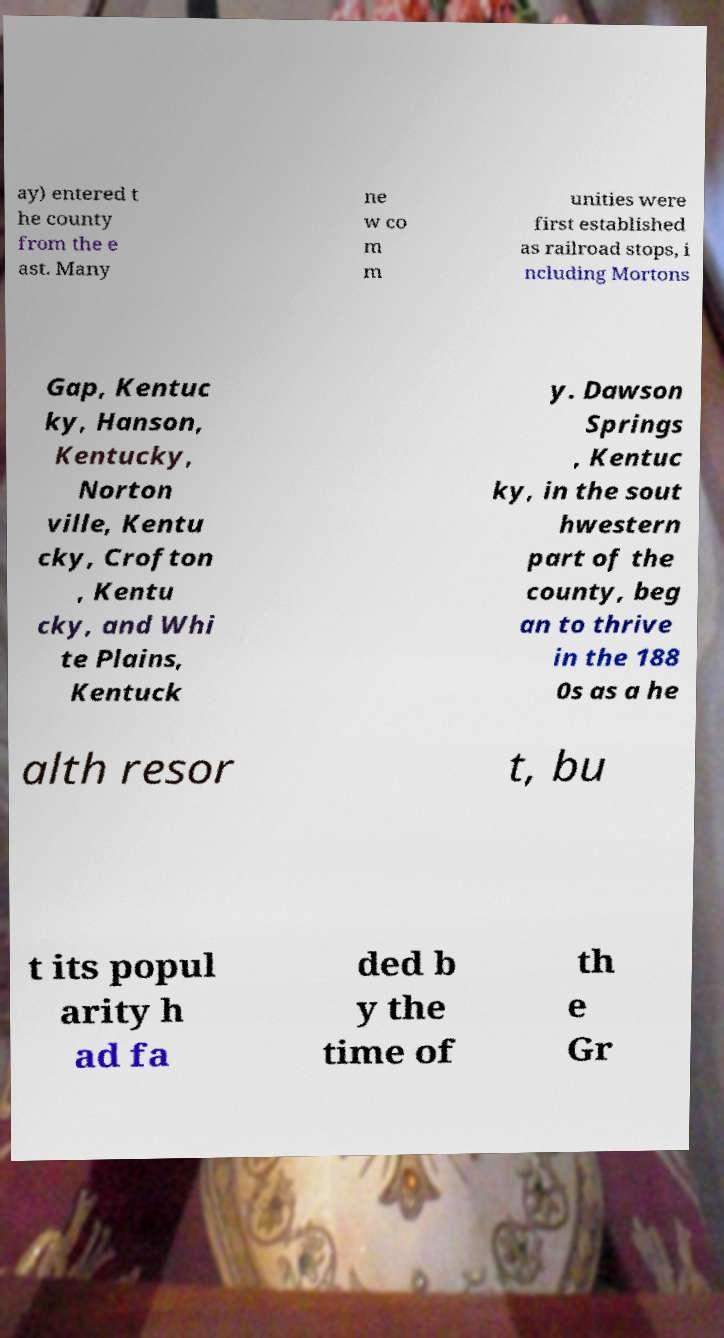Could you extract and type out the text from this image? ay) entered t he county from the e ast. Many ne w co m m unities were first established as railroad stops, i ncluding Mortons Gap, Kentuc ky, Hanson, Kentucky, Norton ville, Kentu cky, Crofton , Kentu cky, and Whi te Plains, Kentuck y. Dawson Springs , Kentuc ky, in the sout hwestern part of the county, beg an to thrive in the 188 0s as a he alth resor t, bu t its popul arity h ad fa ded b y the time of th e Gr 